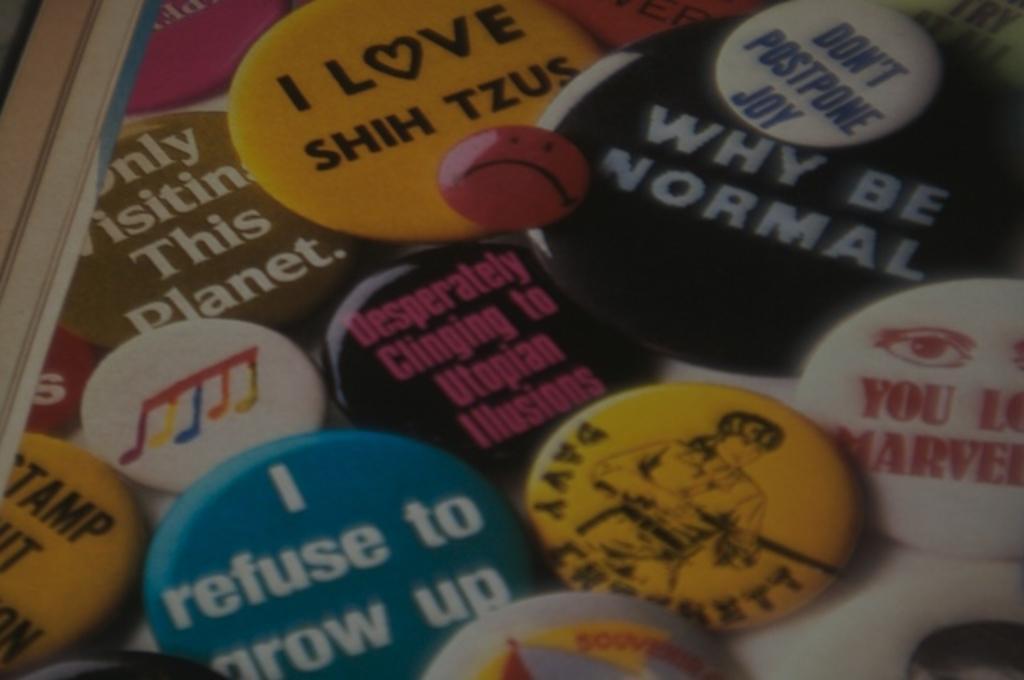In one or two sentences, can you explain what this image depicts? In this picture we can see badges on the surface and a wooden stick. 